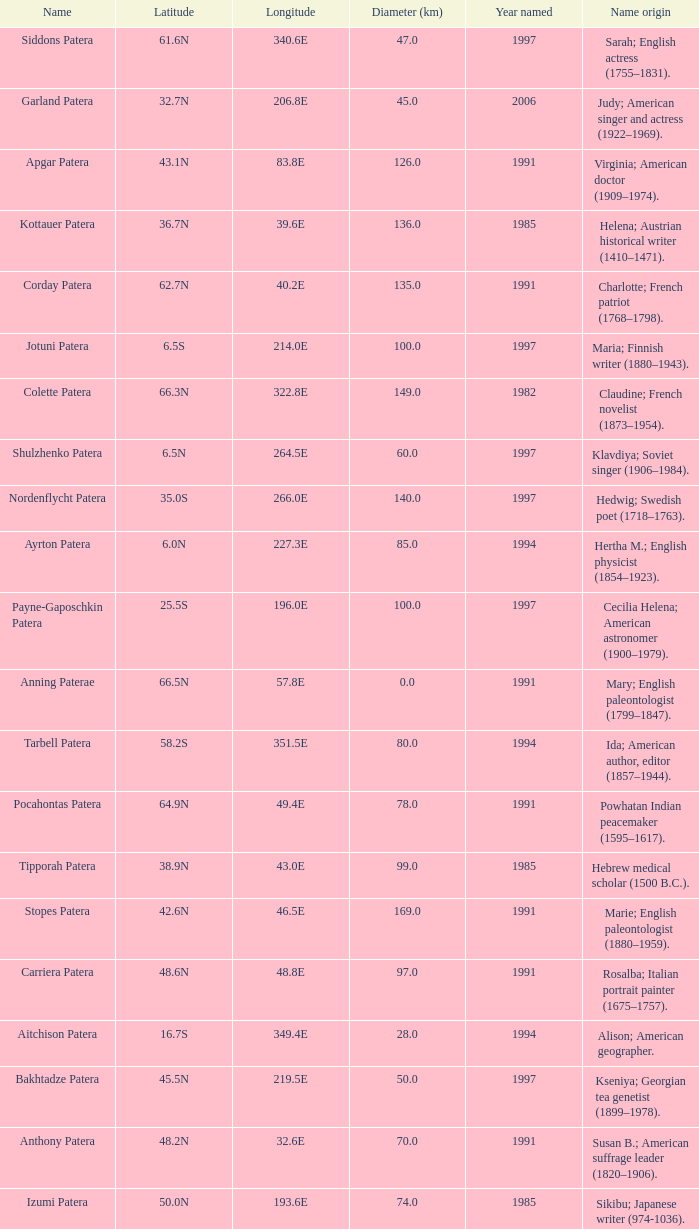What is the diameter in km of the feature named Colette Patera?  149.0. 